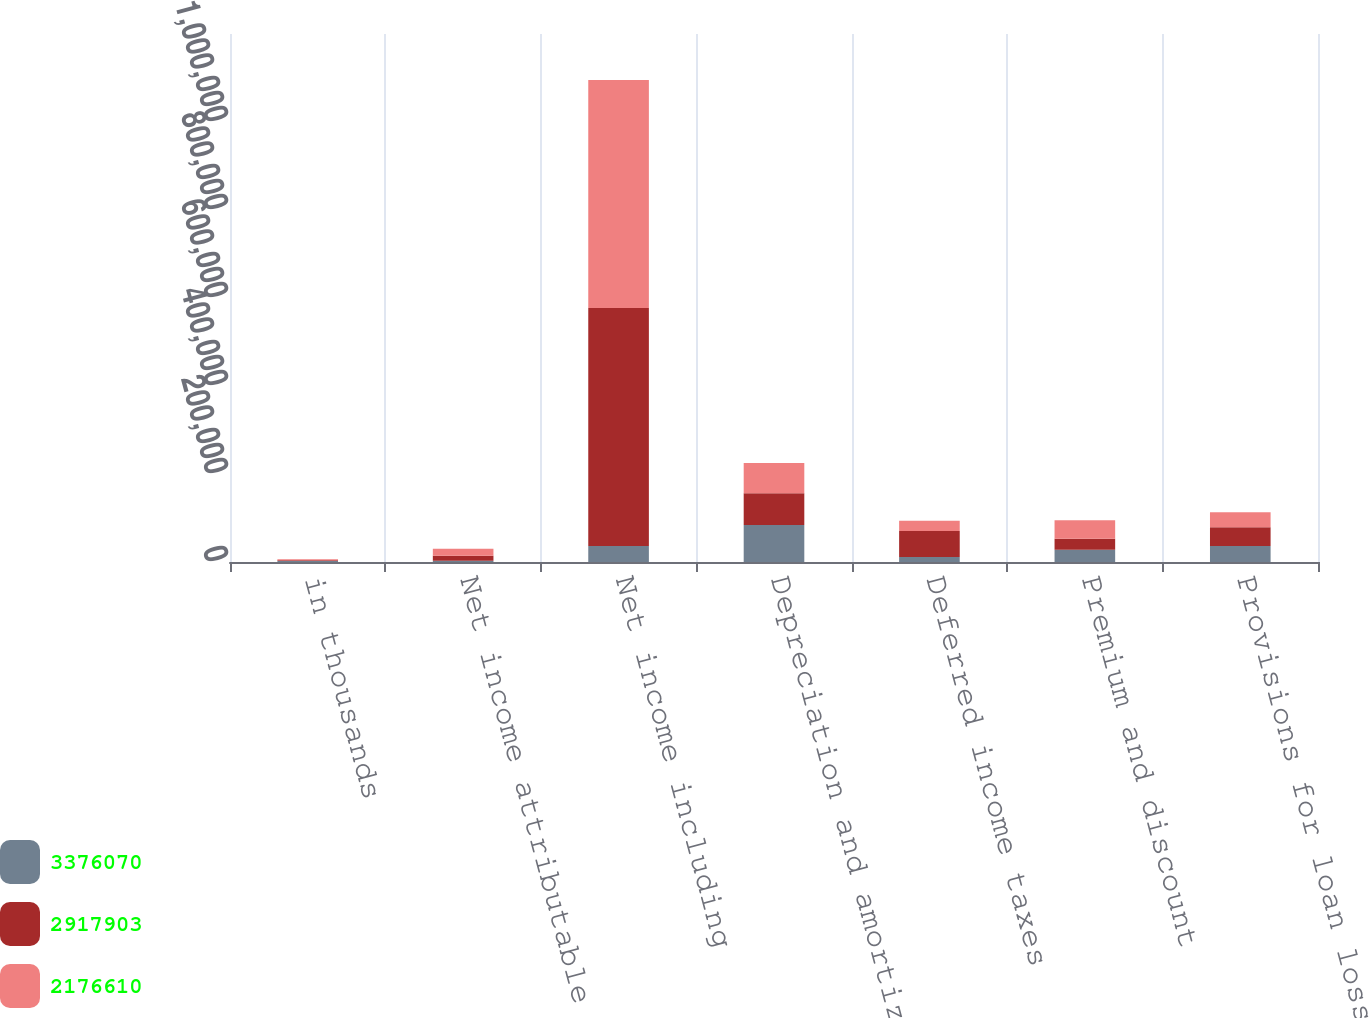<chart> <loc_0><loc_0><loc_500><loc_500><stacked_bar_chart><ecel><fcel>in thousands<fcel>Net income attributable to<fcel>Net income including<fcel>Depreciation and amortization<fcel>Deferred income taxes<fcel>Premium and discount<fcel>Provisions for loan losses<nl><fcel>3.37607e+06<fcel>2017<fcel>2632<fcel>36357<fcel>84132<fcel>11617<fcel>27572<fcel>36357<nl><fcel>2.9179e+06<fcel>2016<fcel>11301<fcel>540651<fcel>72383<fcel>58798<fcel>25010<fcel>42394<nl><fcel>2.17661e+06<fcel>2015<fcel>16438<fcel>518578<fcel>68315<fcel>23462<fcel>42544<fcel>34277<nl></chart> 